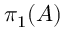<formula> <loc_0><loc_0><loc_500><loc_500>\pi _ { 1 } ( A )</formula> 